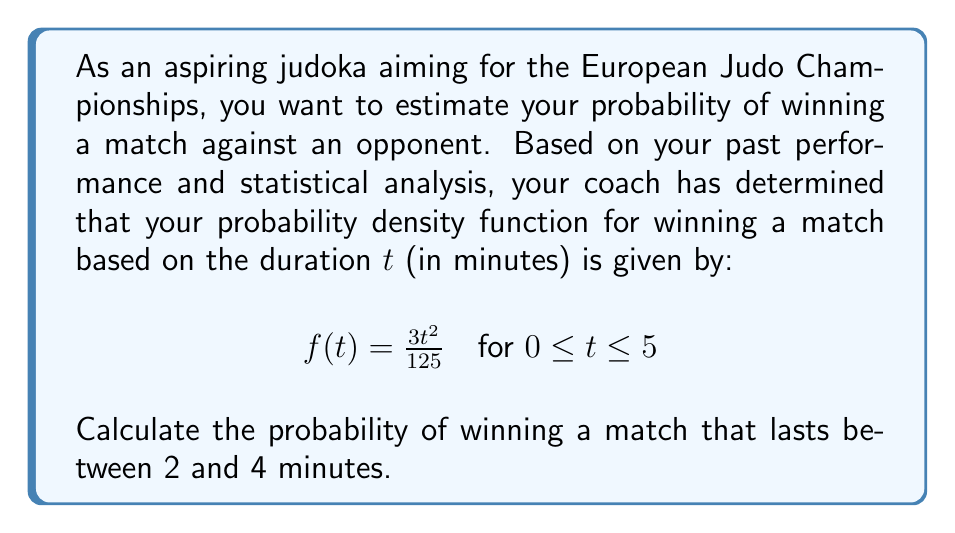Help me with this question. To solve this problem, we need to integrate the probability density function over the given interval. Here's a step-by-step explanation:

1) The probability of winning a match that lasts between 2 and 4 minutes is represented by the area under the curve $f(t)$ from $t=2$ to $t=4$.

2) We can calculate this using a definite integral:

   $$P(2 \leq t \leq 4) = \int_2^4 f(t) dt = \int_2^4 \frac{3t^2}{125} dt$$

3) To evaluate this integral, we use the power rule of integration:

   $$\int_2^4 \frac{3t^2}{125} dt = \frac{3}{125} \int_2^4 t^2 dt = \frac{3}{125} \left[\frac{t^3}{3}\right]_2^4$$

4) Now we evaluate the antiderivative at the limits:

   $$\frac{3}{125} \left[\frac{4^3}{3} - \frac{2^3}{3}\right] = \frac{3}{125} \left[\frac{64}{3} - \frac{8}{3}\right] = \frac{3}{125} \cdot \frac{56}{3}$$

5) Simplify:

   $$\frac{3}{125} \cdot \frac{56}{3} = \frac{56}{125} = 0.448$$

Therefore, the probability of winning a match that lasts between 2 and 4 minutes is 0.448 or 44.8%.
Answer: 0.448 or 44.8% 